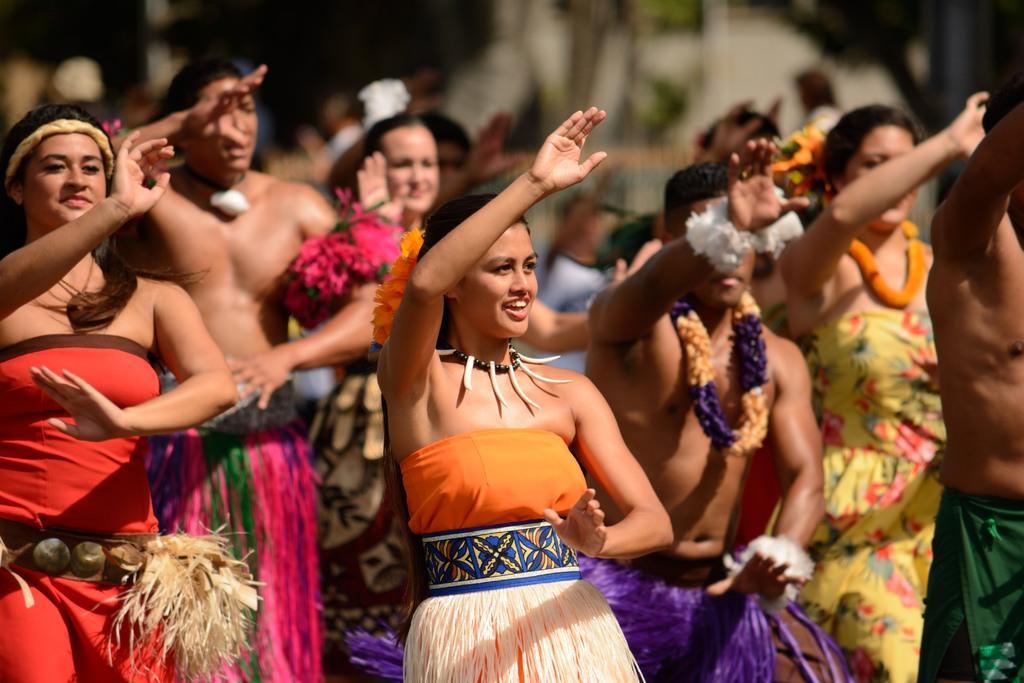Please provide a concise description of this image. In this image we can see people standing on the ground wearing costumes and some are wearing garlands around their necks. 